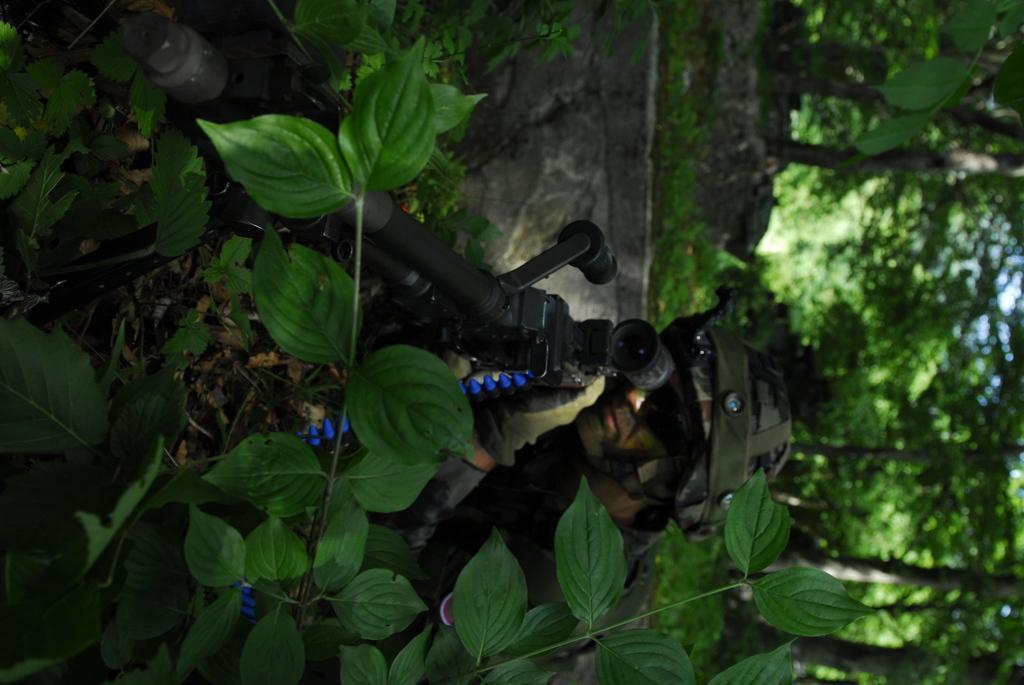Describe this image in one or two sentences. In this image we can see a person holding a gun, there are some plants and trees, also we can see the sky. 